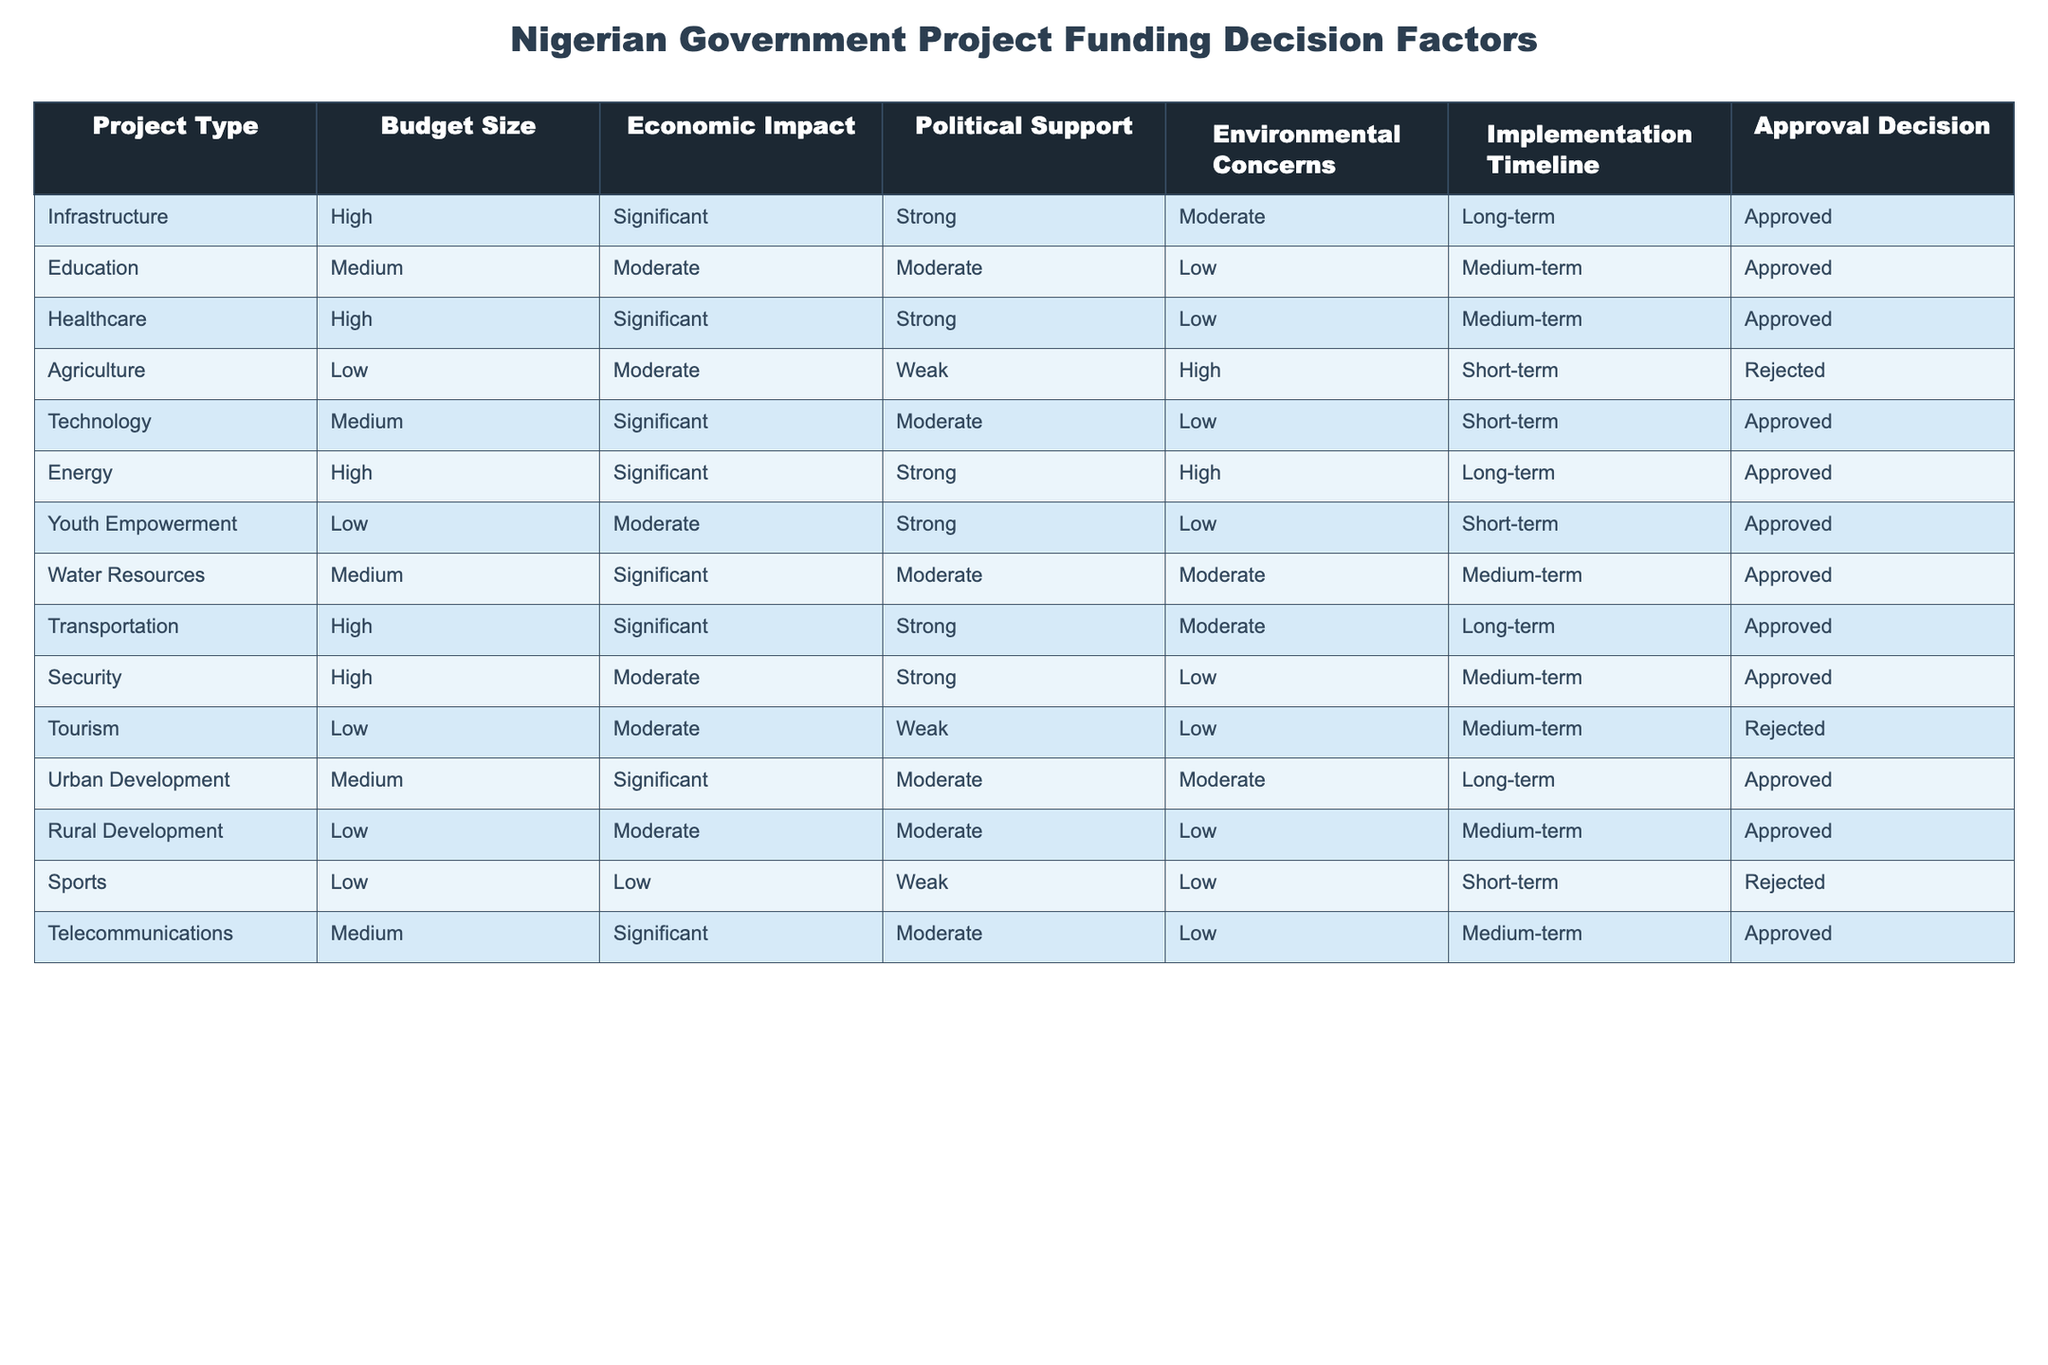What is the approval decision for the Agriculture project? The table shows the approval decision for each project type. Looking at the row for Agriculture, the approval decision is labeled as "Rejected."
Answer: Rejected Which project type has the highest budget size and what is its approval decision? The table lists various project types along with their budget sizes. High budget sizes include Infrastructure, Healthcare, Energy, Transportation, and Security. Each of these has the approval decision marked as "Approved." Therefore, the answer remains consistent across these entries.
Answer: Approved How many projects with a medium budget size were approved? In the table, the projects categorized as having a medium budget size are Education, Technology, Water Resources, and Telecommunications. All four have an "Approved" status. Thus, the total count of medium-budget approved projects is four.
Answer: 4 Is there any project with low environmental concerns that was rejected? The table indicates that there are projects with low environmental concerns, specifically in Healthcare, Youth Empowerment, and all projects listed under low environmental concerns. However, Agriculture and Tourism projects that have low environmental concerns are the only ones that did not get approved. Therefore, the answer is yes to the question of whether any of these projects were rejected.
Answer: Yes What is the difference in the number of rejected projects versus approved projects? The approved projects in the table total eleven, while the rejected projects are Agriculture, Tourism, and Sports, totaling three in number. To find the difference, subtract the number of rejected projects (3) from the number of approved projects (11): 11 - 3 = 8. The difference is eight.
Answer: 8 Which project type has significant economic impact but was rejected? Reviewing the table, we see that Agriculture and Tourism are both labeled with a moderate economic impact and rejected. However, they do not qualify as having a significant economic impact. Therefore, there are no project types with a significant economic impact that were rejected.
Answer: None Are there any projects that have strong political support but a low economic impact? By examining the table, we see that both Healthcare and Youth Empowerment have strong political support. Healthcare has a significant economic impact, whereas Youth Empowerment only has a moderate economic impact. Thus, Youth Empowerment is the only project meeting the criteria of strong political support with lower economic impact.
Answer: Yes What is the implementation timeline for projects that received an "Approved" decision? The table shows various implementation timelines for the projects with "Approved" status. The timelines include long-term for Infrastructure, Healthcare, Energy, Transportation, and Urban Development; medium-term for Education, Technology, Water Resources, and Telecommunications; and short-term for Youth Empowerment. Hence, implementations are categorized by long, medium, and short-term timelines.
Answer: Long-term, Medium-term, Short-term 